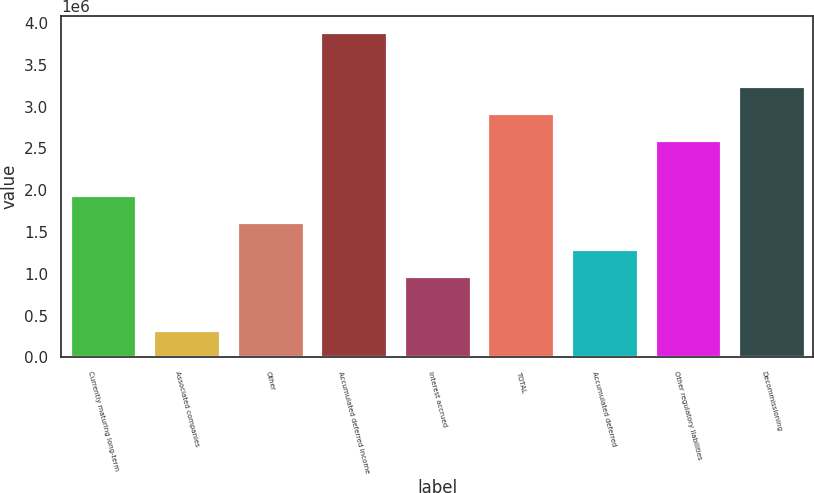Convert chart to OTSL. <chart><loc_0><loc_0><loc_500><loc_500><bar_chart><fcel>Currently maturing long-term<fcel>Associated companies<fcel>Other<fcel>Accumulated deferred income<fcel>Interest accrued<fcel>TOTAL<fcel>Accumulated deferred<fcel>Other regulatory liabilities<fcel>Decommissioning<nl><fcel>1.94859e+06<fcel>327622<fcel>1.6244e+06<fcel>3.89375e+06<fcel>976009<fcel>2.92117e+06<fcel>1.3002e+06<fcel>2.59698e+06<fcel>3.24536e+06<nl></chart> 